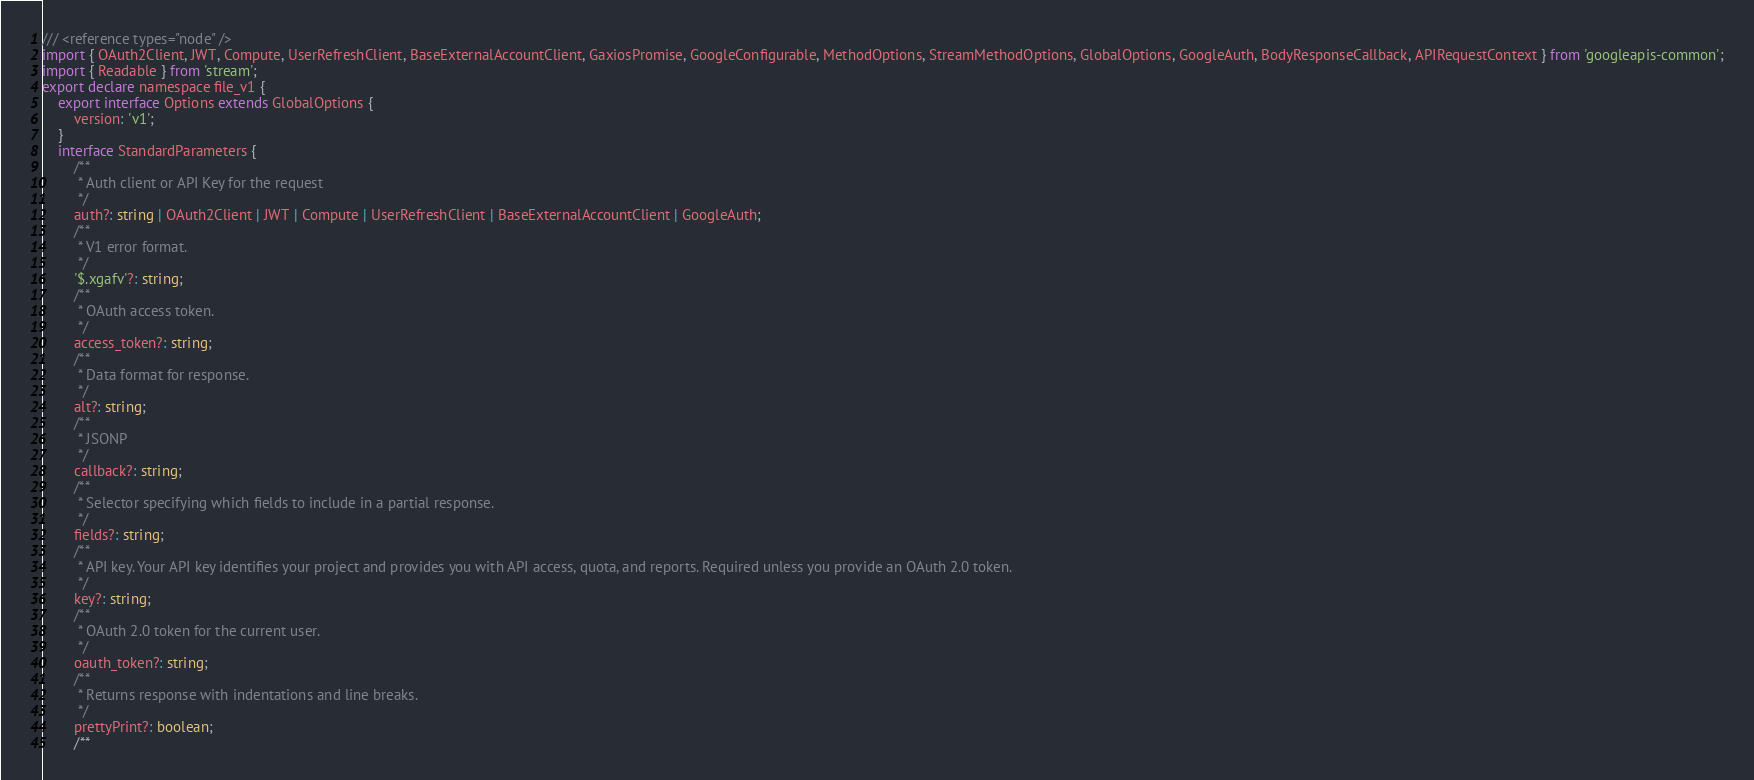<code> <loc_0><loc_0><loc_500><loc_500><_TypeScript_>/// <reference types="node" />
import { OAuth2Client, JWT, Compute, UserRefreshClient, BaseExternalAccountClient, GaxiosPromise, GoogleConfigurable, MethodOptions, StreamMethodOptions, GlobalOptions, GoogleAuth, BodyResponseCallback, APIRequestContext } from 'googleapis-common';
import { Readable } from 'stream';
export declare namespace file_v1 {
    export interface Options extends GlobalOptions {
        version: 'v1';
    }
    interface StandardParameters {
        /**
         * Auth client or API Key for the request
         */
        auth?: string | OAuth2Client | JWT | Compute | UserRefreshClient | BaseExternalAccountClient | GoogleAuth;
        /**
         * V1 error format.
         */
        '$.xgafv'?: string;
        /**
         * OAuth access token.
         */
        access_token?: string;
        /**
         * Data format for response.
         */
        alt?: string;
        /**
         * JSONP
         */
        callback?: string;
        /**
         * Selector specifying which fields to include in a partial response.
         */
        fields?: string;
        /**
         * API key. Your API key identifies your project and provides you with API access, quota, and reports. Required unless you provide an OAuth 2.0 token.
         */
        key?: string;
        /**
         * OAuth 2.0 token for the current user.
         */
        oauth_token?: string;
        /**
         * Returns response with indentations and line breaks.
         */
        prettyPrint?: boolean;
        /**</code> 